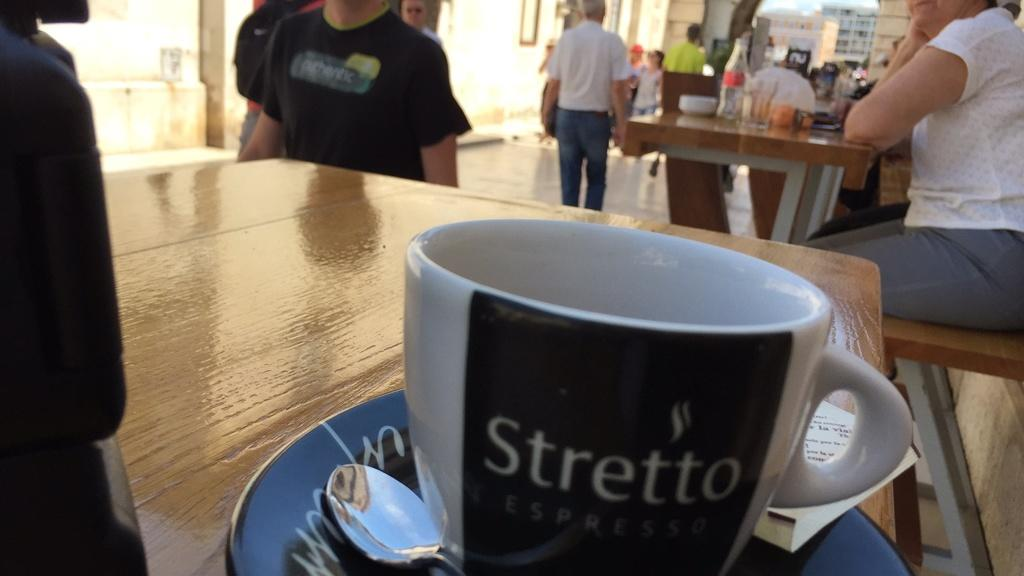How many people are in the image? There are people in the image, but the exact number is not specified. What are the people doing in the image? Some people are sitting, while others are standing. What type of furniture is present in the image? There are tables in the image. What items can be found on the tables? Cups, plates, spoons, and bottles are present on the tables. What type of winter clothing can be seen on the people in the image? There is no mention of winter clothing or any specific season in the image, so it cannot be determined from the facts provided. 